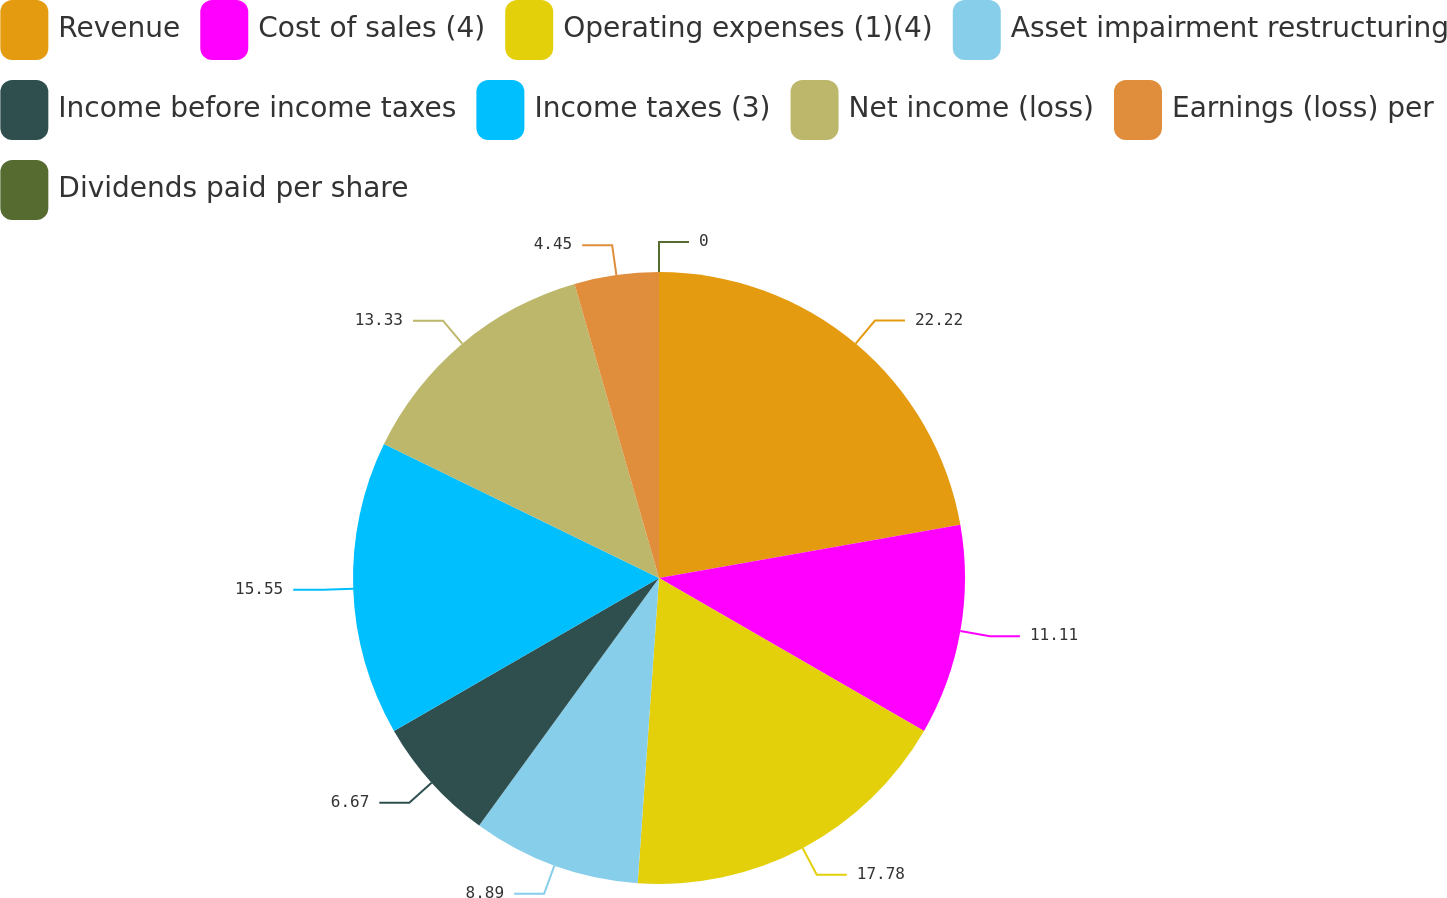<chart> <loc_0><loc_0><loc_500><loc_500><pie_chart><fcel>Revenue<fcel>Cost of sales (4)<fcel>Operating expenses (1)(4)<fcel>Asset impairment restructuring<fcel>Income before income taxes<fcel>Income taxes (3)<fcel>Net income (loss)<fcel>Earnings (loss) per<fcel>Dividends paid per share<nl><fcel>22.22%<fcel>11.11%<fcel>17.78%<fcel>8.89%<fcel>6.67%<fcel>15.55%<fcel>13.33%<fcel>4.45%<fcel>0.0%<nl></chart> 